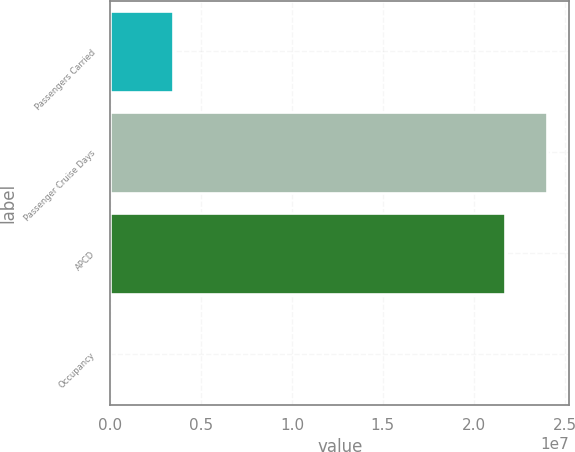<chart> <loc_0><loc_0><loc_500><loc_500><bar_chart><fcel>Passengers Carried<fcel>Passenger Cruise Days<fcel>APCD<fcel>Occupancy<nl><fcel>3.47629e+06<fcel>2.40516e+07<fcel>2.17337e+07<fcel>106.6<nl></chart> 